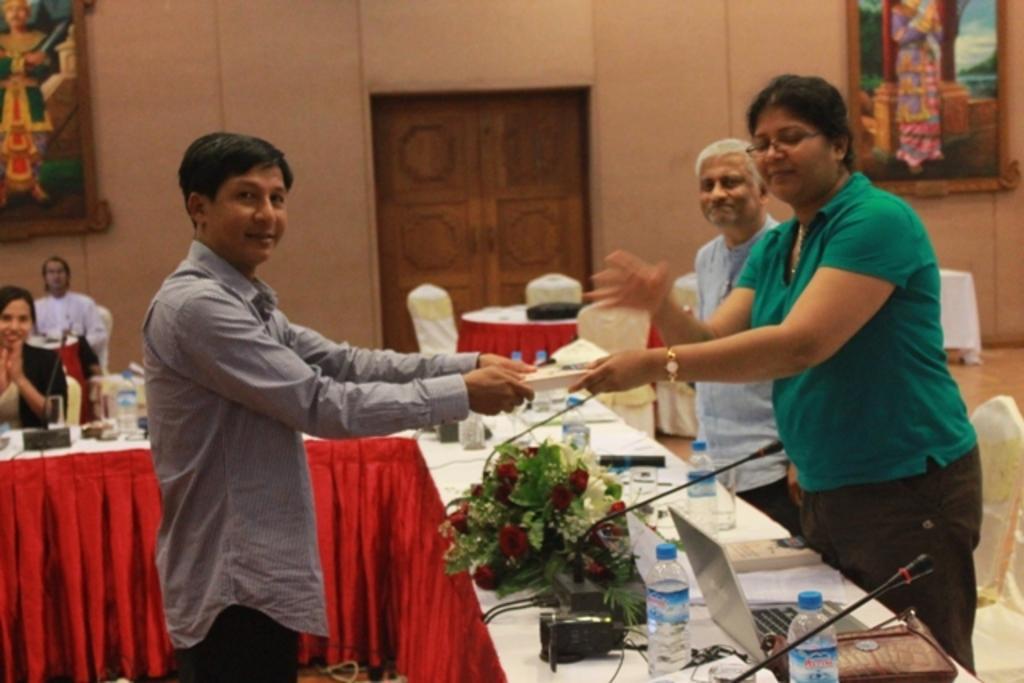How would you summarize this image in a sentence or two? This picture is taken inside the room. In this image, on the right side, we can see a woman wearing a green color shirt is standing in front of the table and holding a object. At the table, we can also see a microphone, water bottle, laptop, purse, electric wires. On the right side, we can also see another person standing in front of the table. On the right side, we can also see some chairs and a photo frame attached to a wall. On the left side, we can see a person and holding an object in his hand and the person standing in front of the table. On the left side, we can see a woman sitting on the chair in front of the table. In the background, we can see a person sitting on the chair, few tables and chairs, door which is closed and a photo frame attached to a wall. 